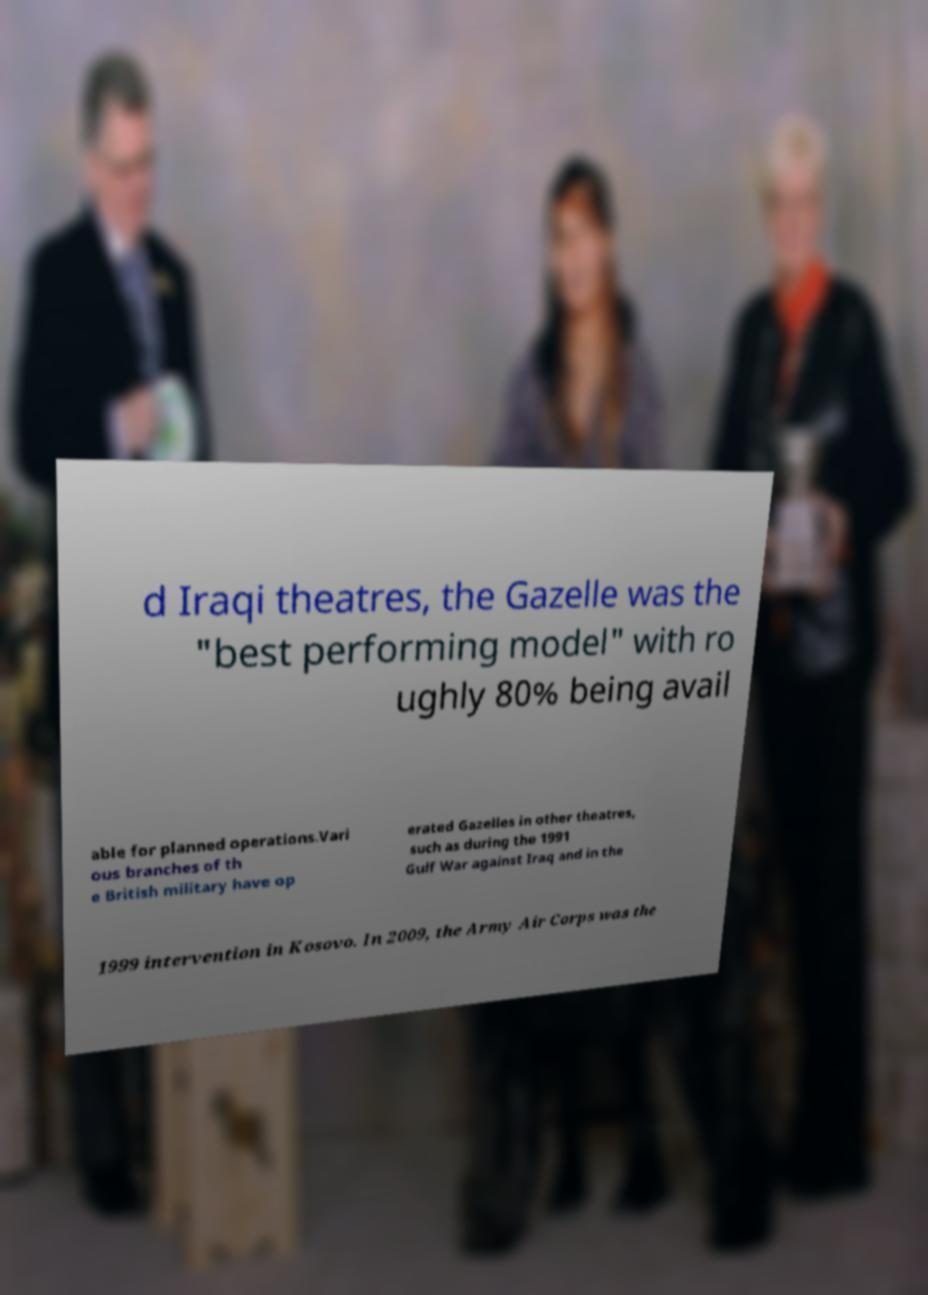Please identify and transcribe the text found in this image. d Iraqi theatres, the Gazelle was the "best performing model" with ro ughly 80% being avail able for planned operations.Vari ous branches of th e British military have op erated Gazelles in other theatres, such as during the 1991 Gulf War against Iraq and in the 1999 intervention in Kosovo. In 2009, the Army Air Corps was the 